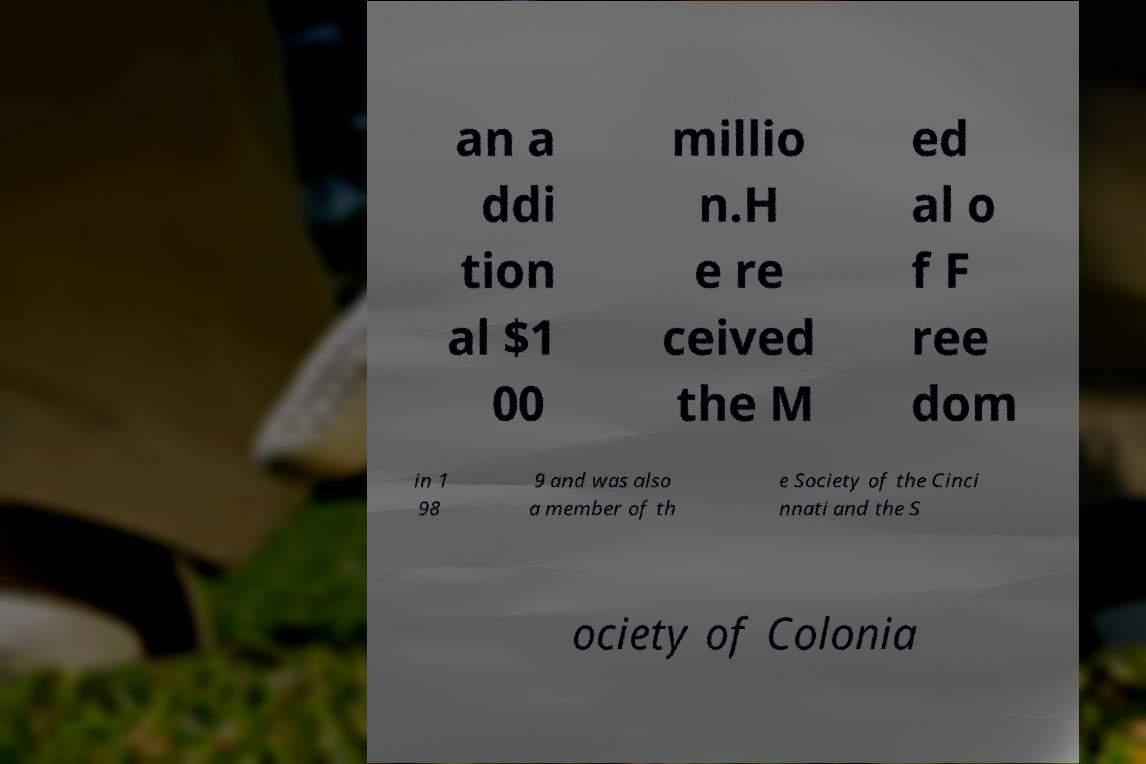There's text embedded in this image that I need extracted. Can you transcribe it verbatim? an a ddi tion al $1 00 millio n.H e re ceived the M ed al o f F ree dom in 1 98 9 and was also a member of th e Society of the Cinci nnati and the S ociety of Colonia 